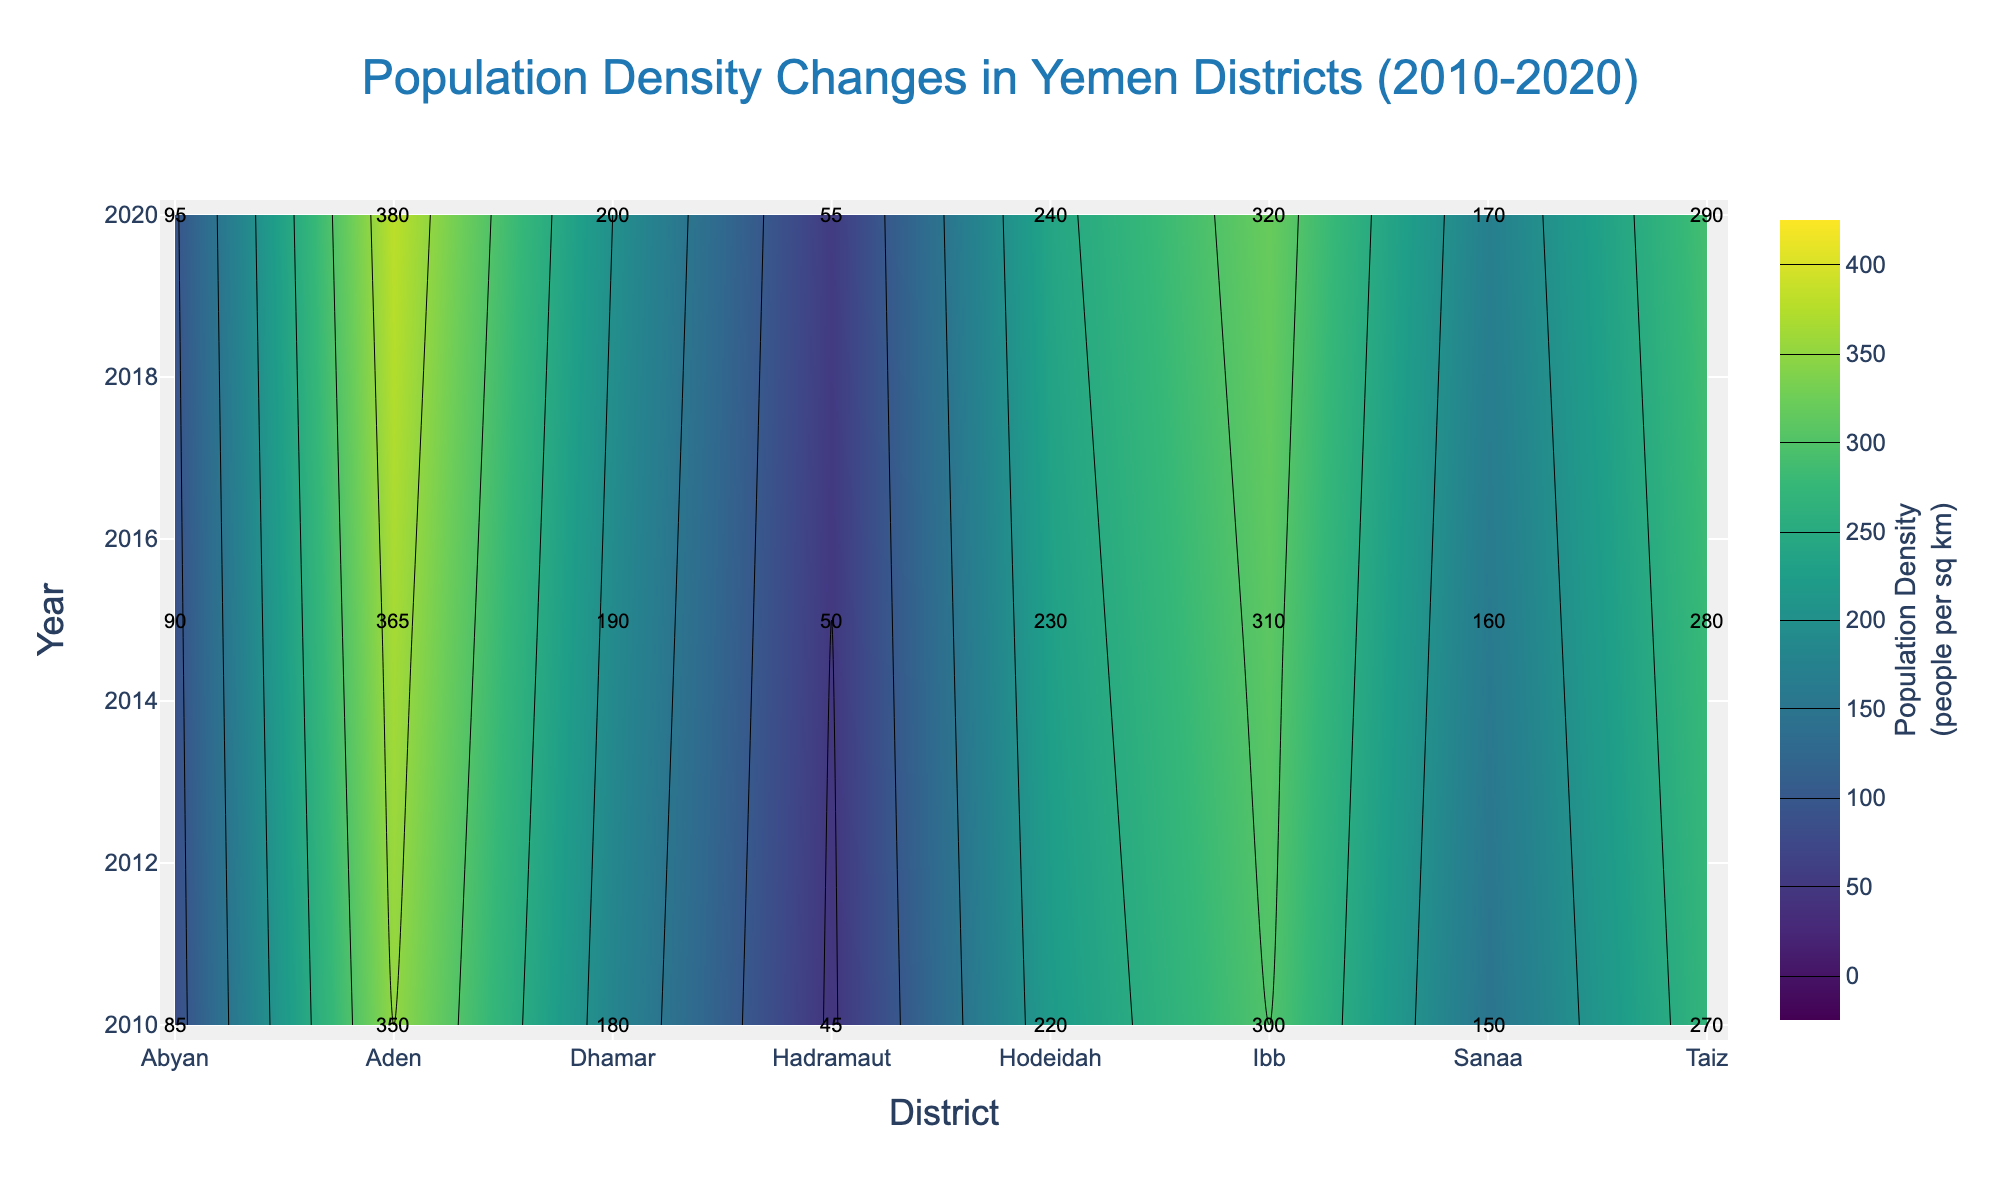What is the title of the figure? The title is usually displayed at the top of the figure and summarizes the content of the plot. In this case, it's easy to spot as "Population Density Changes in Yemen Districts (2010-2020)" is prominently displayed.
Answer: Population Density Changes in Yemen Districts (2010-2020) Which district had the highest population density in 2020? To identify the district with the highest population density in 2020, locate the y-axis value for 2020. Then, refer to the color intensity and annotations for the district with the highest numeric value. Aden has the highest annotated value of 380.
Answer: Aden What are the population densities for Sanaa in 2010 and 2020? Locate the "Sanaa" column on the x-axis, then find the rows corresponding to 2010 and 2020 on the y-axis. The annotated values for these points are 150 for 2010 and 170 for 2020.
Answer: 150 and 170 How did the population density in Hodeidah change from 2010 to 2020? Compare the population density values for Hodeidah in 2010 and 2020. In 2010, the value is 220, and in 2020, it is 240. Subtract 220 from 240 to get the change, resulting in an increase of 20 people per sq km.
Answer: Increased by 20 Which district had a greater increase in population density from 2010 to 2020, Abyan or Dhamar? Calculate the difference in population density between 2010 and 2020 for both districts. Abyan: 95 - 85 = 10; Dhamar: 200 - 180 = 20. Compare the differences, and it shows that Dhamar had a greater increase.
Answer: Dhamar What is the average population density in Taiz over the years 2010, 2015, and 2020? Sum the population densities for Taiz in 2010 (270), 2015 (280), and 2020 (290), which equals 840. Then divide by 3 to get the average: 840 / 3 = 280.
Answer: 280 What is the color range of the contour plot, and what does it represent? The figure uses a color scale from a start value of 0 to an end value of 400, representing the population density (people per sq km). Darker shades indicate higher densities.
Answer: 0 to 400, representing population density Which year shows the lowest population density in Hadramaut, and what is the value? Locate the "Hadramaut" column and compare the values in the years 2010, 2015, and 2020. The lowest value is in 2010, which is 45.
Answer: 2010, 45 